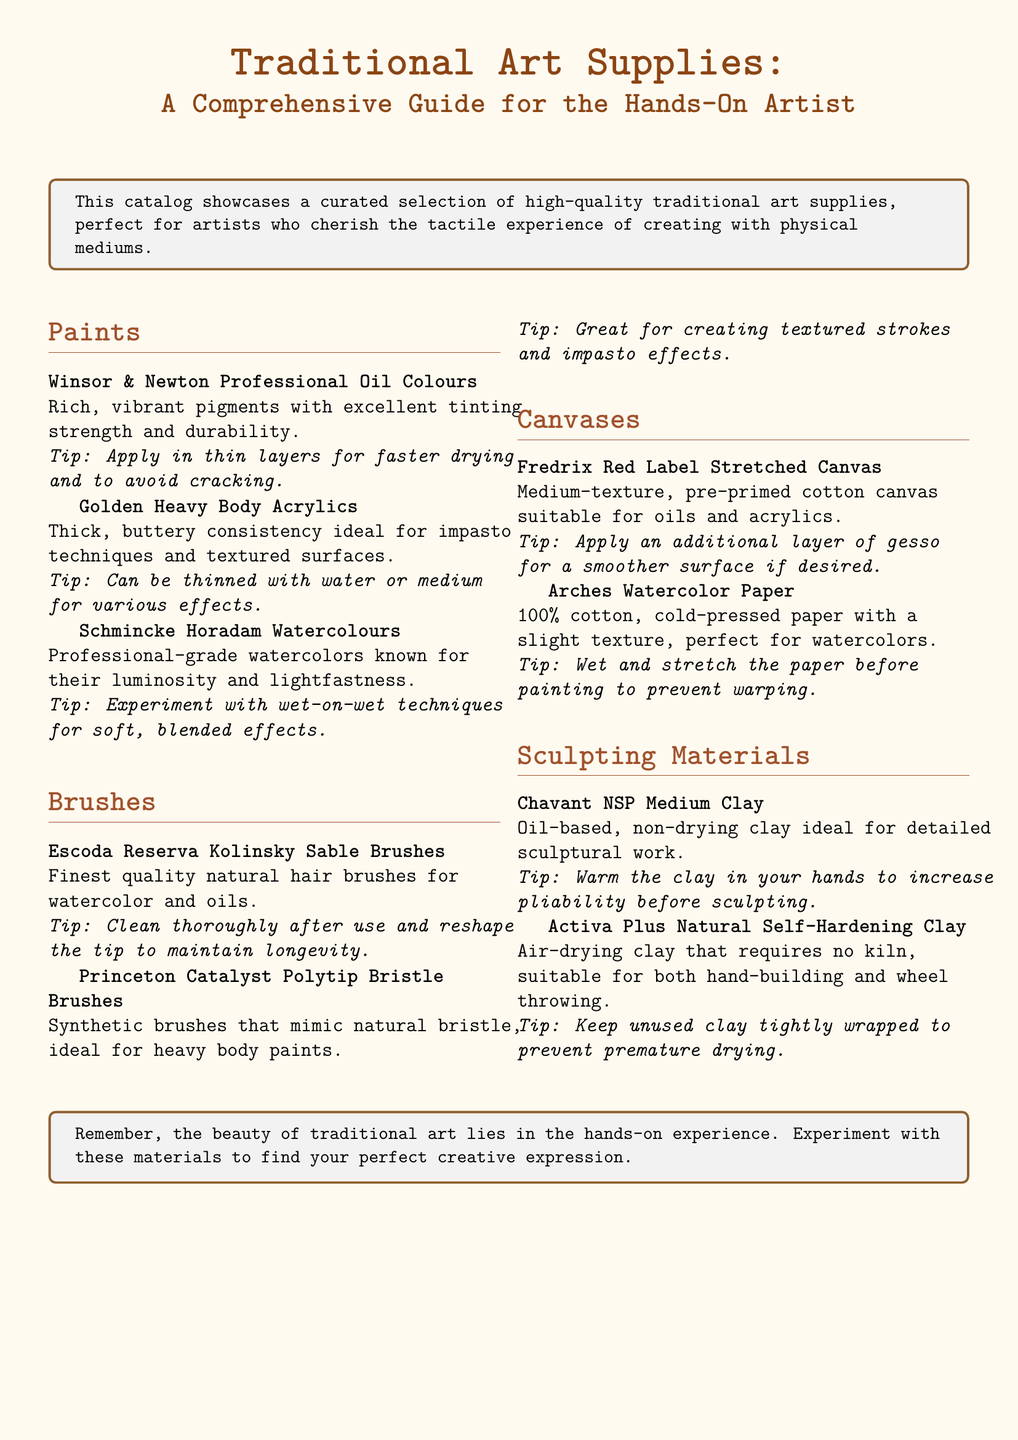What type of canvas is Fredrix Red Label? The document specifies that the Fredrix Red Label is a medium-texture, pre-primed cotton canvas suitable for oils and acrylics.
Answer: medium-texture, pre-primed cotton canvas What is the quality of Escoda Reserva Kolinsky Sable Brushes? The document states these brushes are of the finest quality natural hair.
Answer: finest quality natural hair What are Golden Heavy Body Acrylics ideal for? The document mentions that these acrylics are ideal for impasto techniques and textured surfaces.
Answer: impasto techniques and textured surfaces How should wet paper be prepared before painting? The document advises to wet and stretch the paper before painting to prevent warping.
Answer: wet and stretch What is the primary material of Arches Watercolor Paper? The document reveals that Arches Watercolor Paper is made of 100% cotton.
Answer: 100% cotton What are Chavant NSP Medium Clay's characteristics? The document describes it as oil-based and non-drying, making it ideal for detailed sculptural work.
Answer: oil-based, non-drying What is the main tip for using the Princeton Catalyst Polytip Bristle Brushes? According to the document, the main tip is that they are great for creating textured strokes and impasto effects.
Answer: creating textured strokes and impasto effects How can you increase the pliability of Chavant NSP Medium Clay? The document suggests warming the clay in your hands to increase pliability before sculpting.
Answer: warm in your hands What type of paint is Winsor & Newton Professional Oil Colours? The document refers to it as oil colors.
Answer: oil colors 